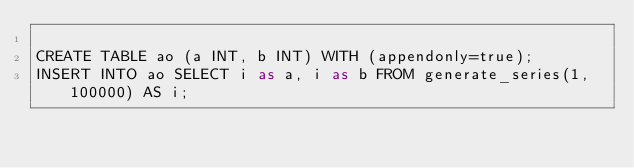<code> <loc_0><loc_0><loc_500><loc_500><_SQL_>
CREATE TABLE ao (a INT, b INT) WITH (appendonly=true);
INSERT INTO ao SELECT i as a, i as b FROM generate_series(1, 100000) AS i;

</code> 